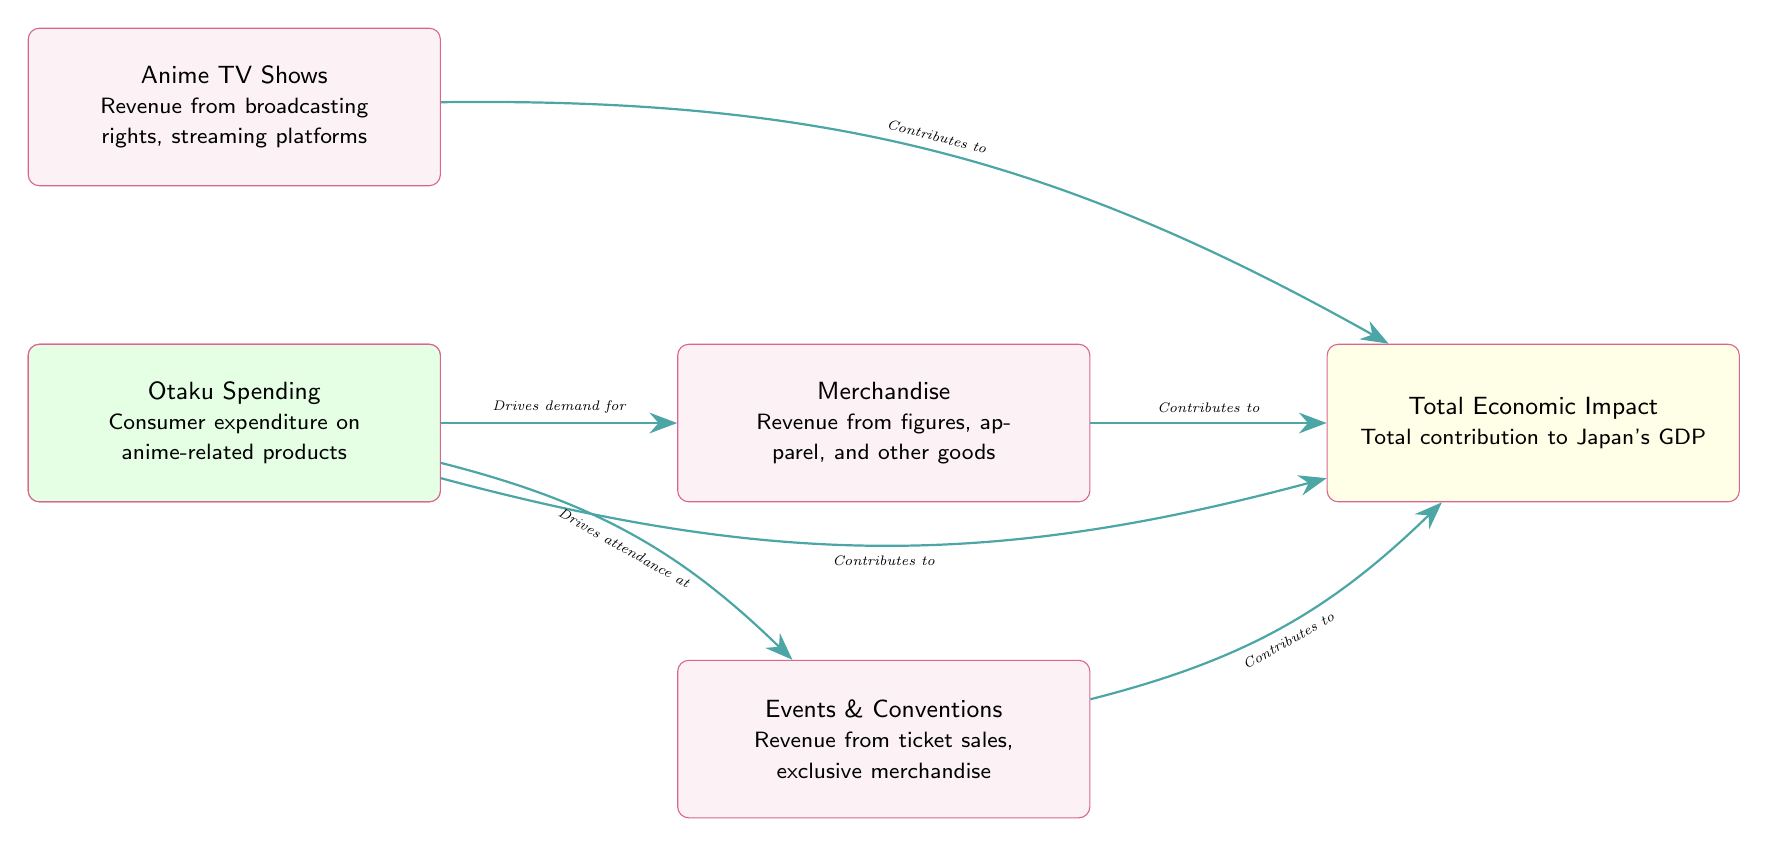What's the total economic impact of the anime industry in Japan? The diagram indicates that the total economic impact is listed under the node labeled "Total Economic Impact," which states "Total contribution to Japan's GDP." This suggests that the impact is economic in nature but does not specify a numerical value.
Answer: Total contribution to Japan's GDP How many main revenue streams are shown in the diagram? The diagram displays five main revenue streams: Anime TV Shows, Anime Movies, Merchandise, Events & Conventions, and Otaku Spending. This counts as five distinct nodes representing revenue streams.
Answer: 5 What drives the demand for merchandise? The diagram shows the "Otaku Spending" node with an arrow pointing to the "Merchandise" node, labeled "Drives demand for," indicating that Otaku Spending is the driving factor for merchandise sales.
Answer: Otaku Spending Which revenue stream contributes to events and conventions? Referring to the diagram, the "Events & Conventions" node has an arrow from the "Otaku Spending" node labeled "Drives attendance at," indicating that the events and conventions are fueled by Otaku Spending rather than direct revenue streams.
Answer: Otaku Spending What is the relationship between anime movies and total economic impact? The diagram illustrates an arrow from the "Anime Movies" node towards the "Total Economic Impact" node labeled "Contributes to," indicating a direct contribution of anime movies to the total economic impact of the industry.
Answer: Contributes to Which element has a primary focus on figures and apparel? The node labeled "Merchandise" specifically mentions "Revenue from figures, apparel, and other goods," indicating that this element of the diagram is primarily focused on those items.
Answer: Merchandise 